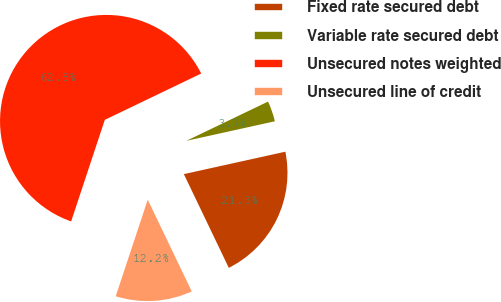<chart> <loc_0><loc_0><loc_500><loc_500><pie_chart><fcel>Fixed rate secured debt<fcel>Variable rate secured debt<fcel>Unsecured notes weighted<fcel>Unsecured line of credit<nl><fcel>21.34%<fcel>3.67%<fcel>62.78%<fcel>12.21%<nl></chart> 